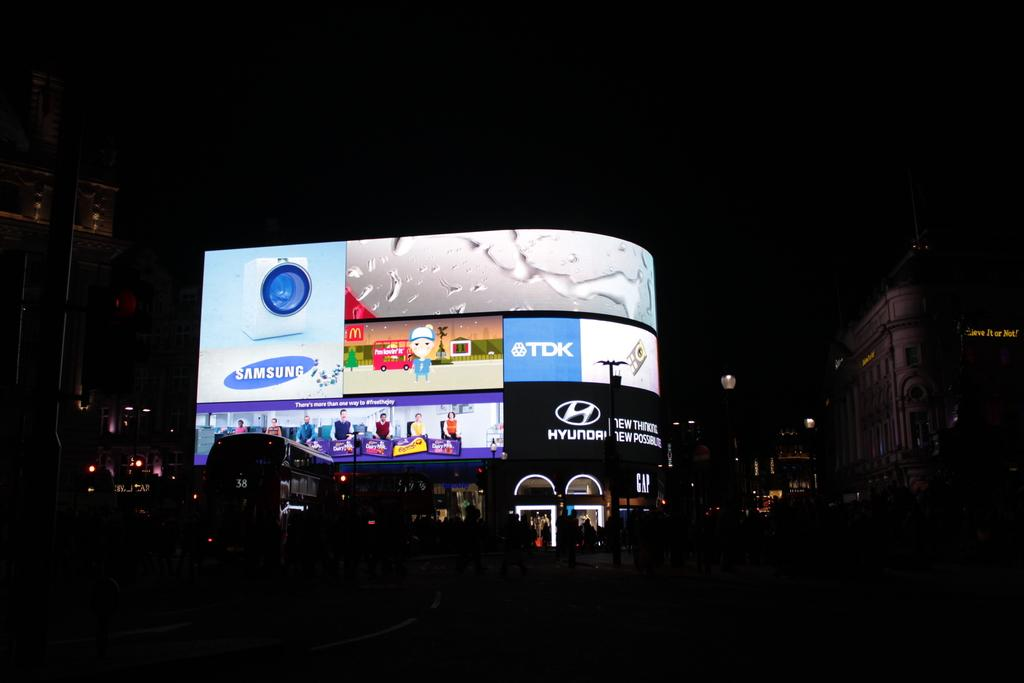<image>
Offer a succinct explanation of the picture presented. a large Samsung advertisement on a building outside 